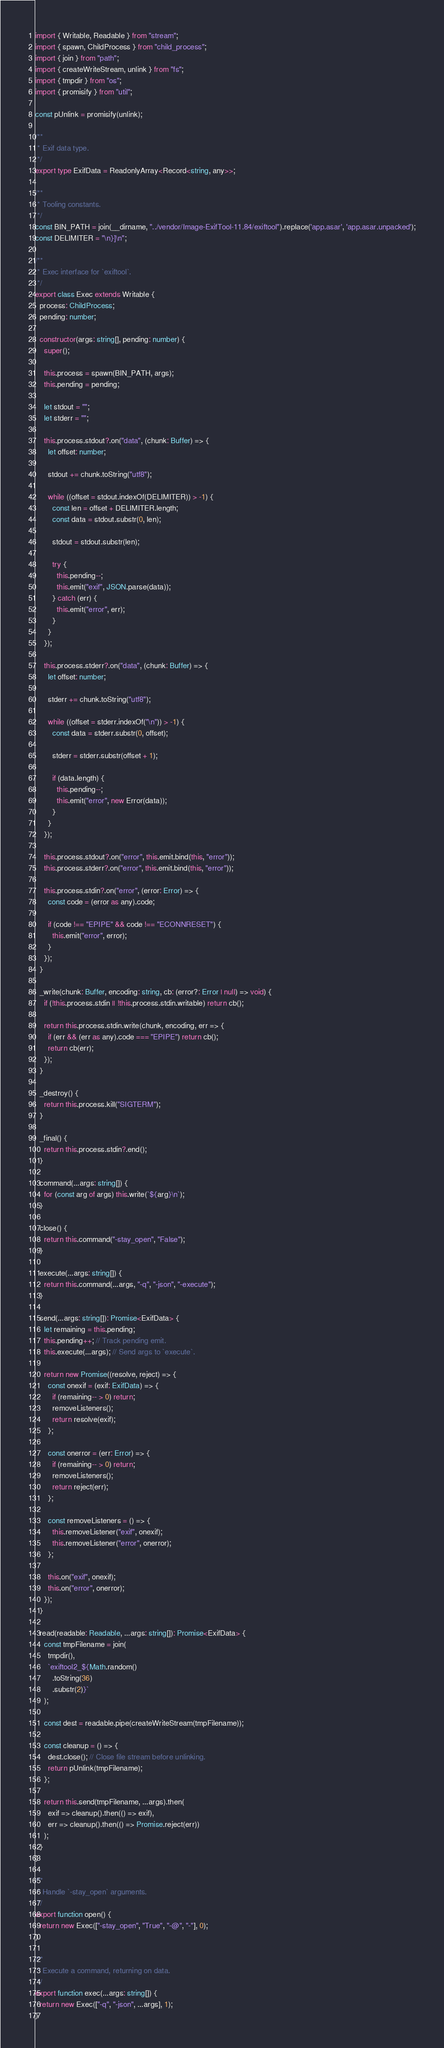Convert code to text. <code><loc_0><loc_0><loc_500><loc_500><_TypeScript_>import { Writable, Readable } from "stream";
import { spawn, ChildProcess } from "child_process";
import { join } from "path";
import { createWriteStream, unlink } from "fs";
import { tmpdir } from "os";
import { promisify } from "util";

const pUnlink = promisify(unlink);

/**
 * Exif data type.
 */
export type ExifData = ReadonlyArray<Record<string, any>>;

/**
 * Tooling constants.
 */
const BIN_PATH = join(__dirname, "../vendor/Image-ExifTool-11.84/exiftool").replace('app.asar', 'app.asar.unpacked');
const DELIMITER = "\n}]\n";

/**
 * Exec interface for `exiftool`.
 */
export class Exec extends Writable {
  process: ChildProcess;
  pending: number;

  constructor(args: string[], pending: number) {
    super();

    this.process = spawn(BIN_PATH, args);
    this.pending = pending;

    let stdout = "";
    let stderr = "";

    this.process.stdout?.on("data", (chunk: Buffer) => {
      let offset: number;

      stdout += chunk.toString("utf8");

      while ((offset = stdout.indexOf(DELIMITER)) > -1) {
        const len = offset + DELIMITER.length;
        const data = stdout.substr(0, len);

        stdout = stdout.substr(len);

        try {
          this.pending--;
          this.emit("exif", JSON.parse(data));
        } catch (err) {
          this.emit("error", err);
        }
      }
    });

    this.process.stderr?.on("data", (chunk: Buffer) => {
      let offset: number;

      stderr += chunk.toString("utf8");

      while ((offset = stderr.indexOf("\n")) > -1) {
        const data = stderr.substr(0, offset);

        stderr = stderr.substr(offset + 1);

        if (data.length) {
          this.pending--;
          this.emit("error", new Error(data));
        }
      }
    });

    this.process.stdout?.on("error", this.emit.bind(this, "error"));
    this.process.stderr?.on("error", this.emit.bind(this, "error"));

    this.process.stdin?.on("error", (error: Error) => {
      const code = (error as any).code;

      if (code !== "EPIPE" && code !== "ECONNRESET") {
        this.emit("error", error);
      }
    });
  }

  _write(chunk: Buffer, encoding: string, cb: (error?: Error | null) => void) {
    if (!this.process.stdin || !this.process.stdin.writable) return cb();

    return this.process.stdin.write(chunk, encoding, err => {
      if (err && (err as any).code === "EPIPE") return cb();
      return cb(err);
    });
  }

  _destroy() {
    return this.process.kill("SIGTERM");
  }

  _final() {
    return this.process.stdin?.end();
  }

  command(...args: string[]) {
    for (const arg of args) this.write(`${arg}\n`);
  }

  close() {
    return this.command("-stay_open", "False");
  }

  execute(...args: string[]) {
    return this.command(...args, "-q", "-json", "-execute");
  }

  send(...args: string[]): Promise<ExifData> {
    let remaining = this.pending;
    this.pending++; // Track pending emit.
    this.execute(...args); // Send args to `execute`.

    return new Promise((resolve, reject) => {
      const onexif = (exif: ExifData) => {
        if (remaining-- > 0) return;
        removeListeners();
        return resolve(exif);
      };

      const onerror = (err: Error) => {
        if (remaining-- > 0) return;
        removeListeners();
        return reject(err);
      };

      const removeListeners = () => {
        this.removeListener("exif", onexif);
        this.removeListener("error", onerror);
      };

      this.on("exif", onexif);
      this.on("error", onerror);
    });
  }

  read(readable: Readable, ...args: string[]): Promise<ExifData> {
    const tmpFilename = join(
      tmpdir(),
      `exiftool2_${Math.random()
        .toString(36)
        .substr(2)}`
    );

    const dest = readable.pipe(createWriteStream(tmpFilename));

    const cleanup = () => {
      dest.close(); // Close file stream before unlinking.
      return pUnlink(tmpFilename);
    };

    return this.send(tmpFilename, ...args).then(
      exif => cleanup().then(() => exif),
      err => cleanup().then(() => Promise.reject(err))
    );
  }
}

/**
 * Handle `-stay_open` arguments.
 */
export function open() {
  return new Exec(["-stay_open", "True", "-@", "-"], 0);
}

/**
 * Execute a command, returning on data.
 */
export function exec(...args: string[]) {
  return new Exec(["-q", "-json", ...args], 1);
}
</code> 